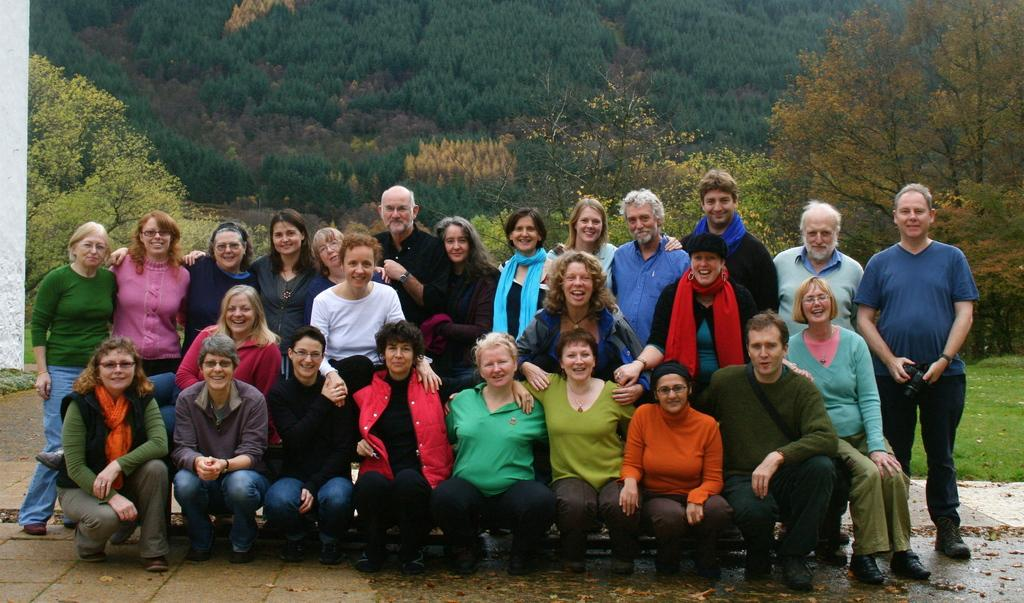How many people are in the group in the image? There is a group of people in the image, but the exact number is not specified. What are the people in the group doing? Some people in the group are crouching, while others are standing behind the crouching individuals. What can be seen in the background of the image? There are trees in the background of the image. What type of card is being used by the people in the image? There is no card present in the image. Where is the library located in the image? There is no library present in the image. 